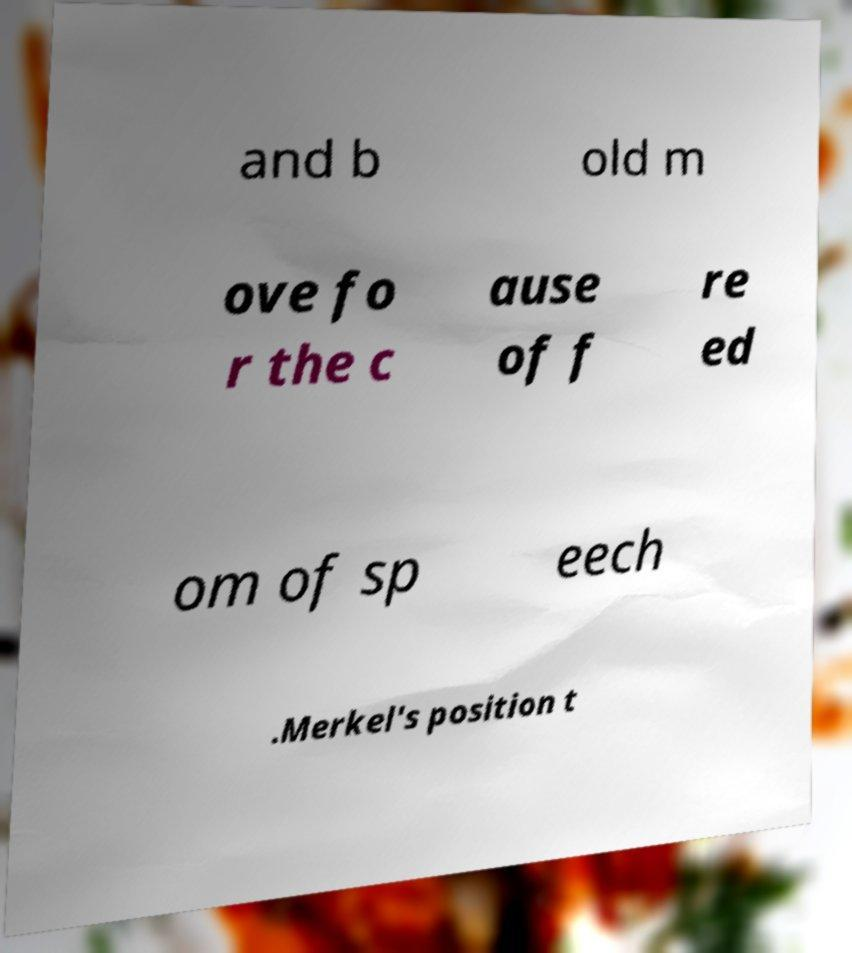Are there any notable visual features in the image besides the text? Yes, besides the partial text, the image shows the paper with a creased texture, and it's placed on a background that appears blurred and could possibly include foliage, indicating it might have been taken outdoors or against a natural backdrop. 